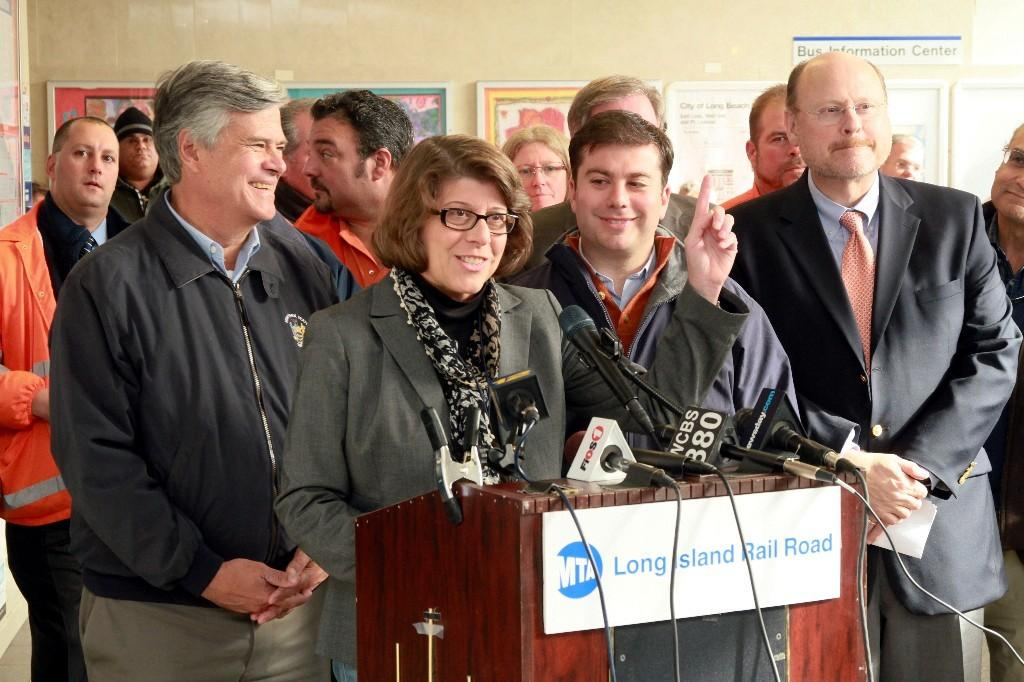How many persons are visible in the image? There are persons standing in the image. What surface are the persons standing on? The persons are standing on the floor. What equipment can be seen in the image? There are mics attached to cables in the image. Where are the mics placed? The mics are placed on a podium. What type of decorations are present in the image? There are wall hangings in the image. How are the wall hangings attached to the room? The wall hangings are attached to a wall. What is the tax rate for the street depicted in the image? There is no street or tax rate mentioned in the image; it focuses on persons, mics, and wall hangings. 